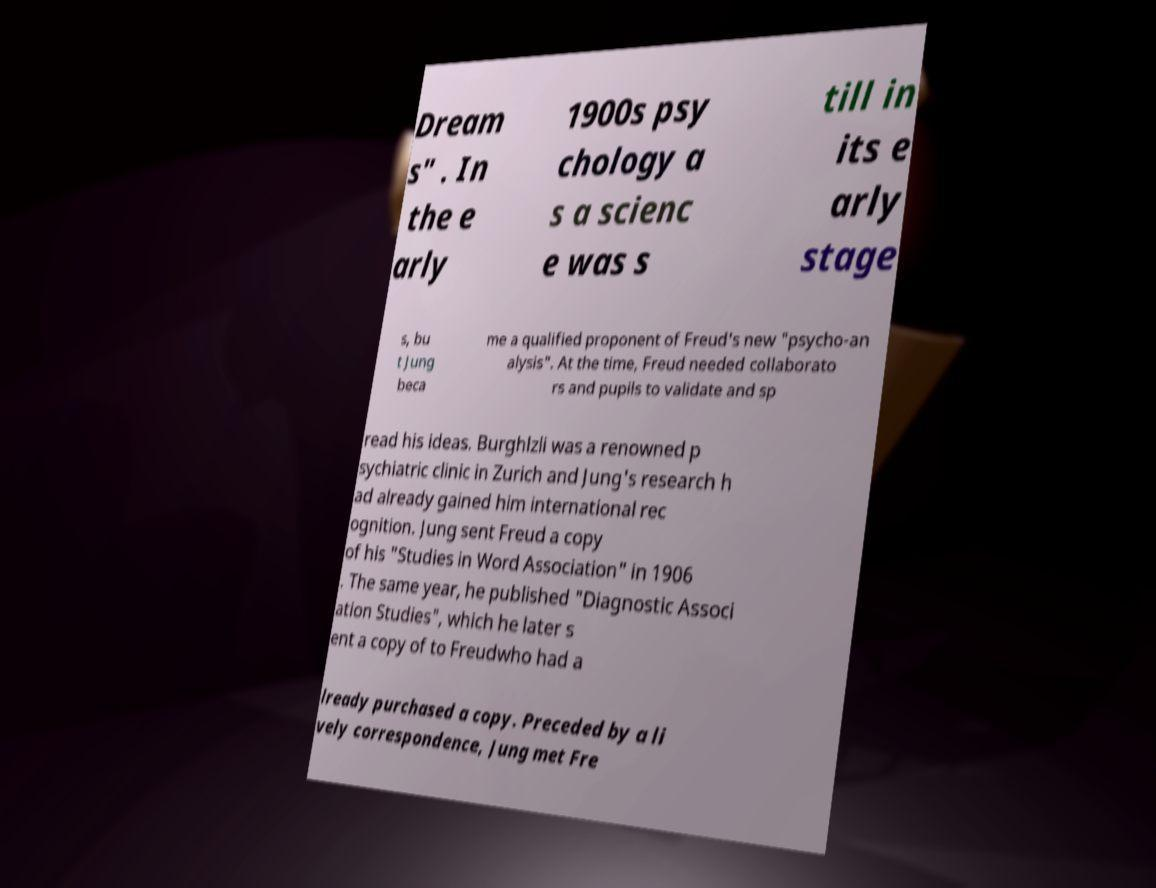There's text embedded in this image that I need extracted. Can you transcribe it verbatim? Dream s" . In the e arly 1900s psy chology a s a scienc e was s till in its e arly stage s, bu t Jung beca me a qualified proponent of Freud's new "psycho-an alysis". At the time, Freud needed collaborato rs and pupils to validate and sp read his ideas. Burghlzli was a renowned p sychiatric clinic in Zurich and Jung's research h ad already gained him international rec ognition. Jung sent Freud a copy of his "Studies in Word Association" in 1906 . The same year, he published "Diagnostic Associ ation Studies", which he later s ent a copy of to Freudwho had a lready purchased a copy. Preceded by a li vely correspondence, Jung met Fre 